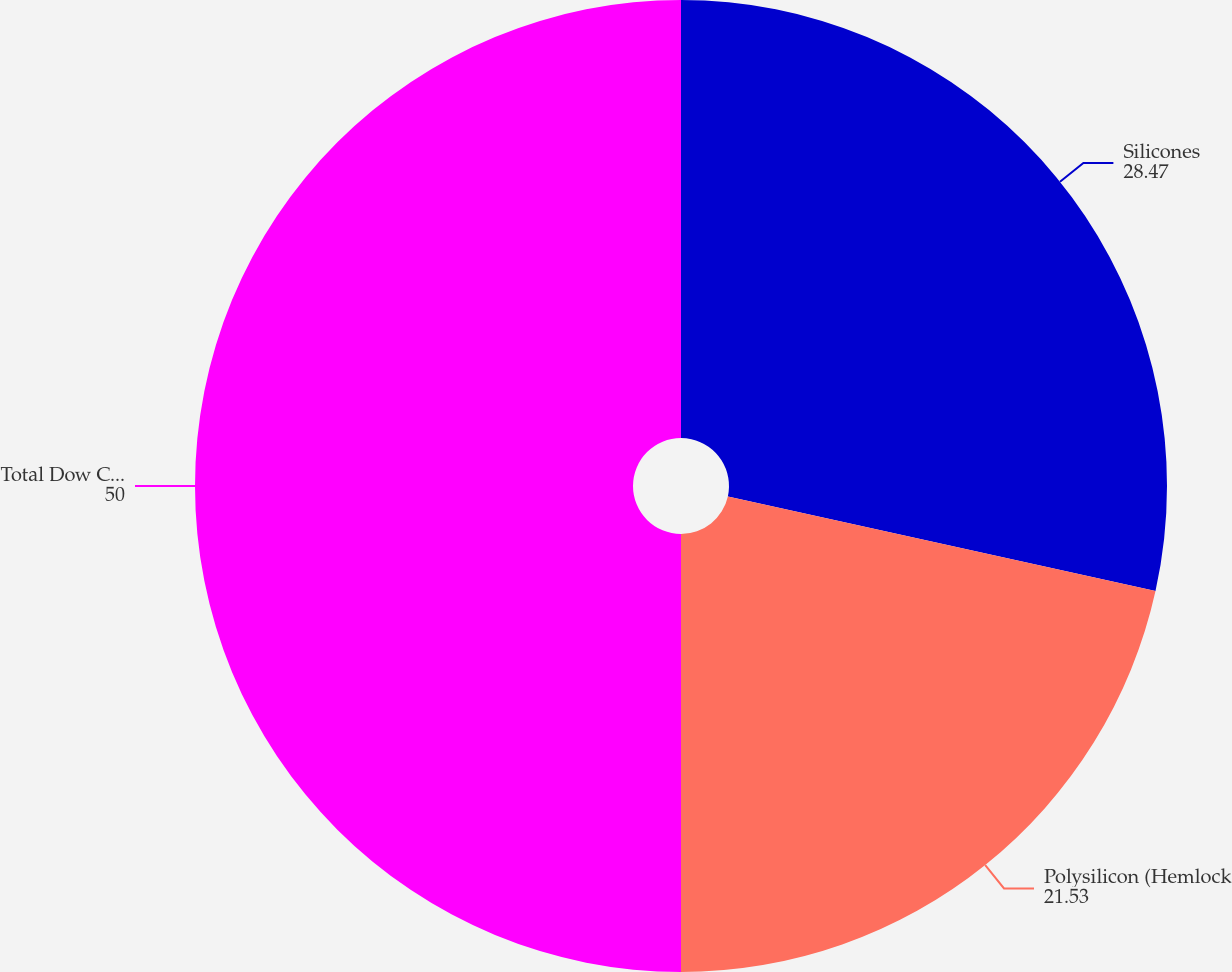Convert chart. <chart><loc_0><loc_0><loc_500><loc_500><pie_chart><fcel>Silicones<fcel>Polysilicon (Hemlock<fcel>Total Dow Corning<nl><fcel>28.47%<fcel>21.53%<fcel>50.0%<nl></chart> 